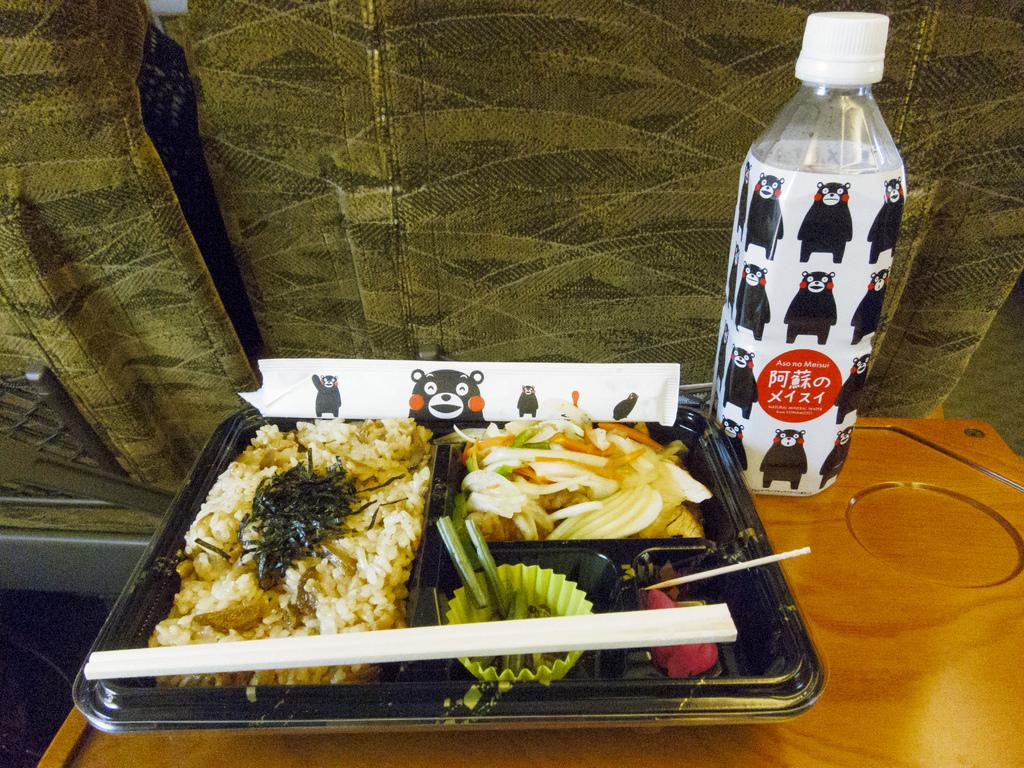<image>
Relay a brief, clear account of the picture shown. The beverage description of natural mineral water on the red label. 